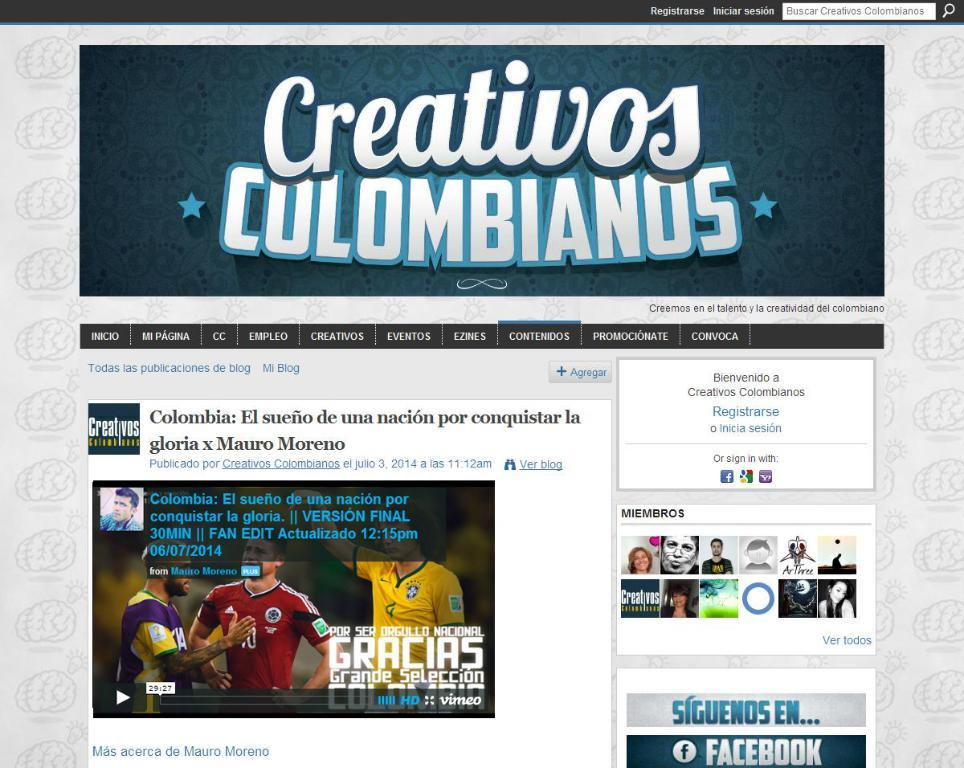What is the main subject of the image? The main subject of the image is a web page. What can be found on the web page? There is text on the web page. Can you describe the people in the image? There are people on both sides of the image. What type of angle is used to hold the rod in the image? There is no rod or angle present in the image; it features a web page with text and people on both sides. 